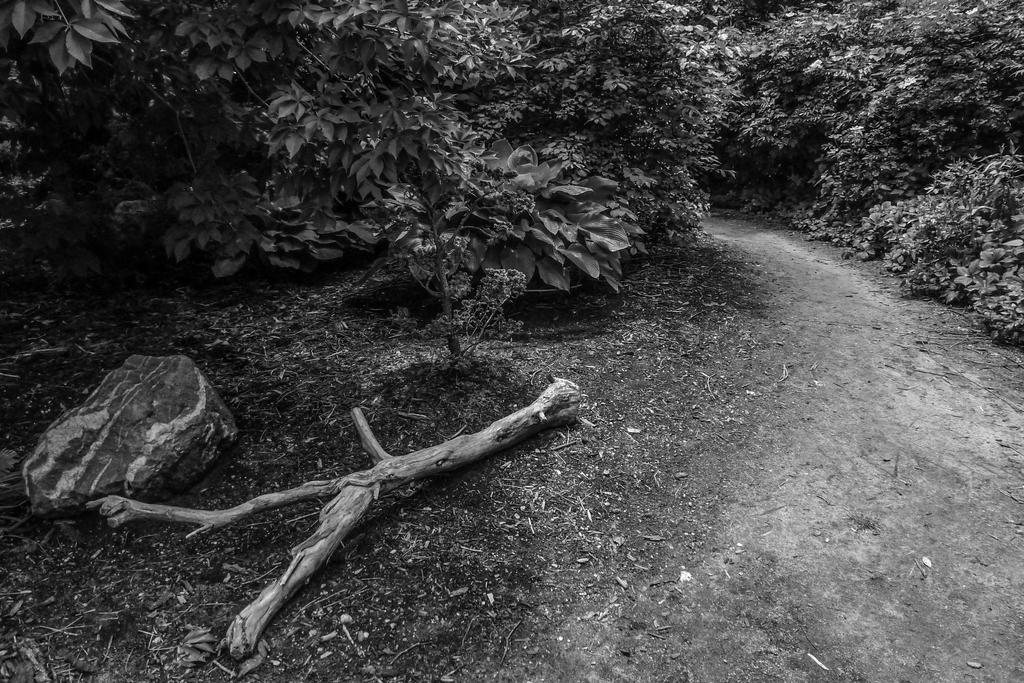What type of vegetation is in the middle of the image? There are trees in the middle of the image. What can be found in the bottom left corner of the image? There is a stem and a stone in the bottom left corner of the image. What historical event is depicted in the image? There is no historical event depicted in the image; it features trees, a stem, and a stone. What type of worm can be seen crawling on the stone in the image? There are no worms present in the image; it only features trees, a stem, and a stone. 